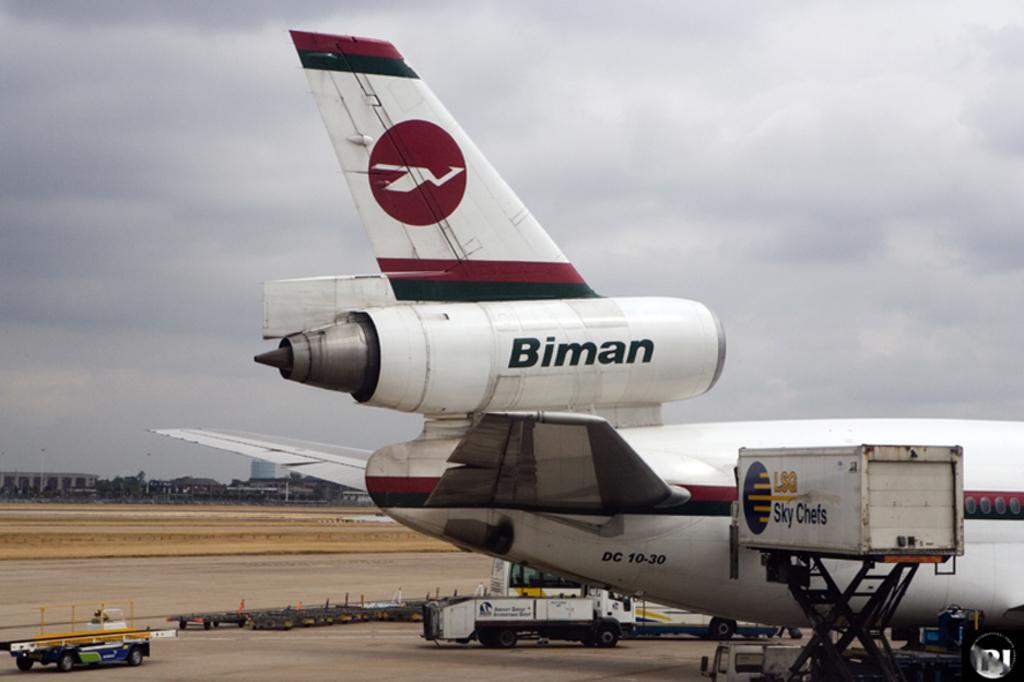Provide a one-sentence caption for the provided image. A maroon, white and black plane shown with the word Binman on it. 